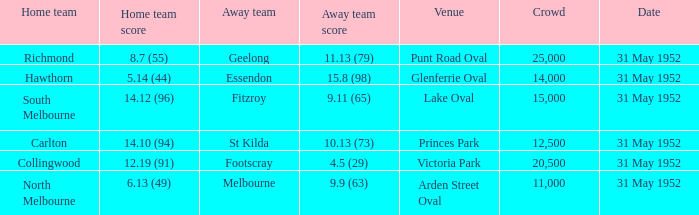Who was the away team at the game at Victoria Park? Footscray. 